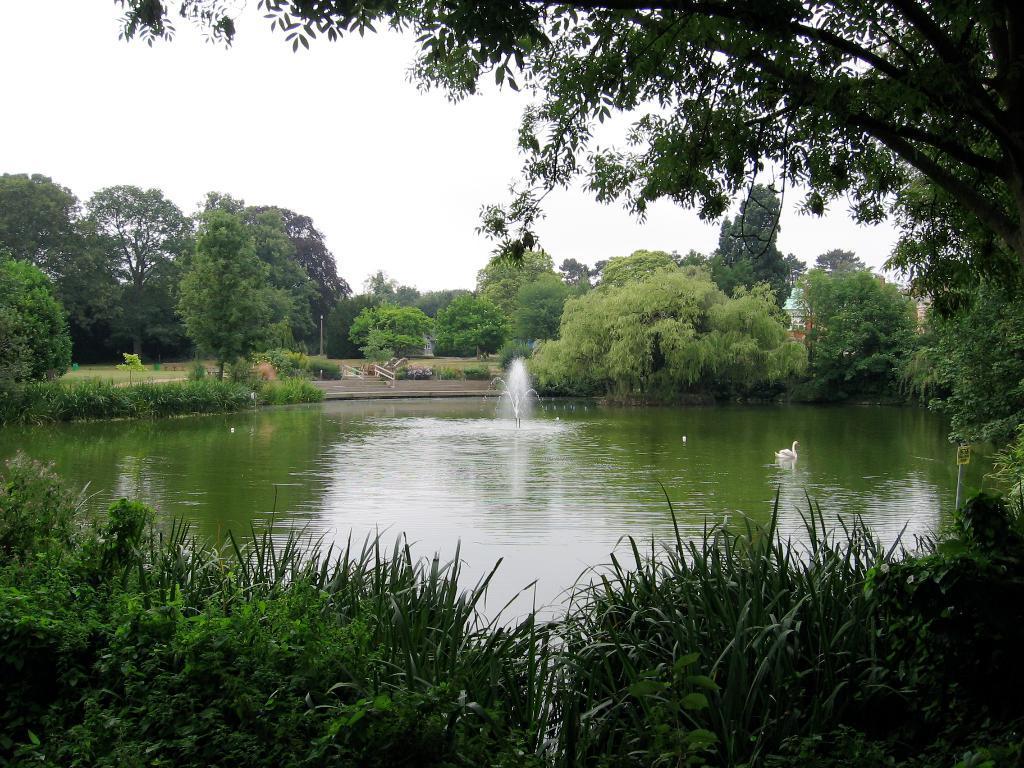Could you give a brief overview of what you see in this image? In this picture I can see a fountain in the middle, in the background there are trees. At the top there is the sky. 